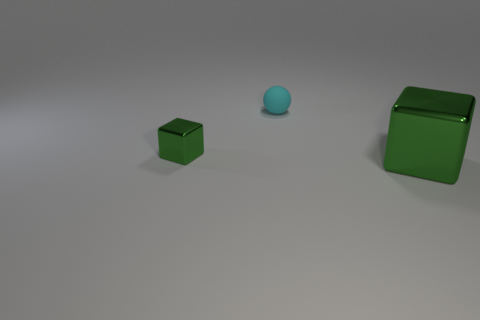There is a green metallic thing that is to the right of the small green block; does it have the same shape as the small metal thing?
Provide a short and direct response. Yes. What number of things are green metal cubes that are behind the large green shiny block or tiny gray blocks?
Make the answer very short. 1. What color is the large object that is the same shape as the tiny green object?
Offer a very short reply. Green. Is there anything else that is the same color as the rubber ball?
Ensure brevity in your answer.  No. How big is the green metallic cube that is to the left of the cyan thing?
Ensure brevity in your answer.  Small. Is the color of the small matte thing the same as the metal cube that is to the right of the matte thing?
Offer a terse response. No. What number of other objects are there of the same material as the small green object?
Make the answer very short. 1. Are there more small green things than big yellow matte things?
Provide a succinct answer. Yes. There is a small thing on the left side of the tiny cyan rubber object; is it the same color as the big metal cube?
Your answer should be compact. Yes. What color is the tiny metallic thing?
Offer a very short reply. Green. 